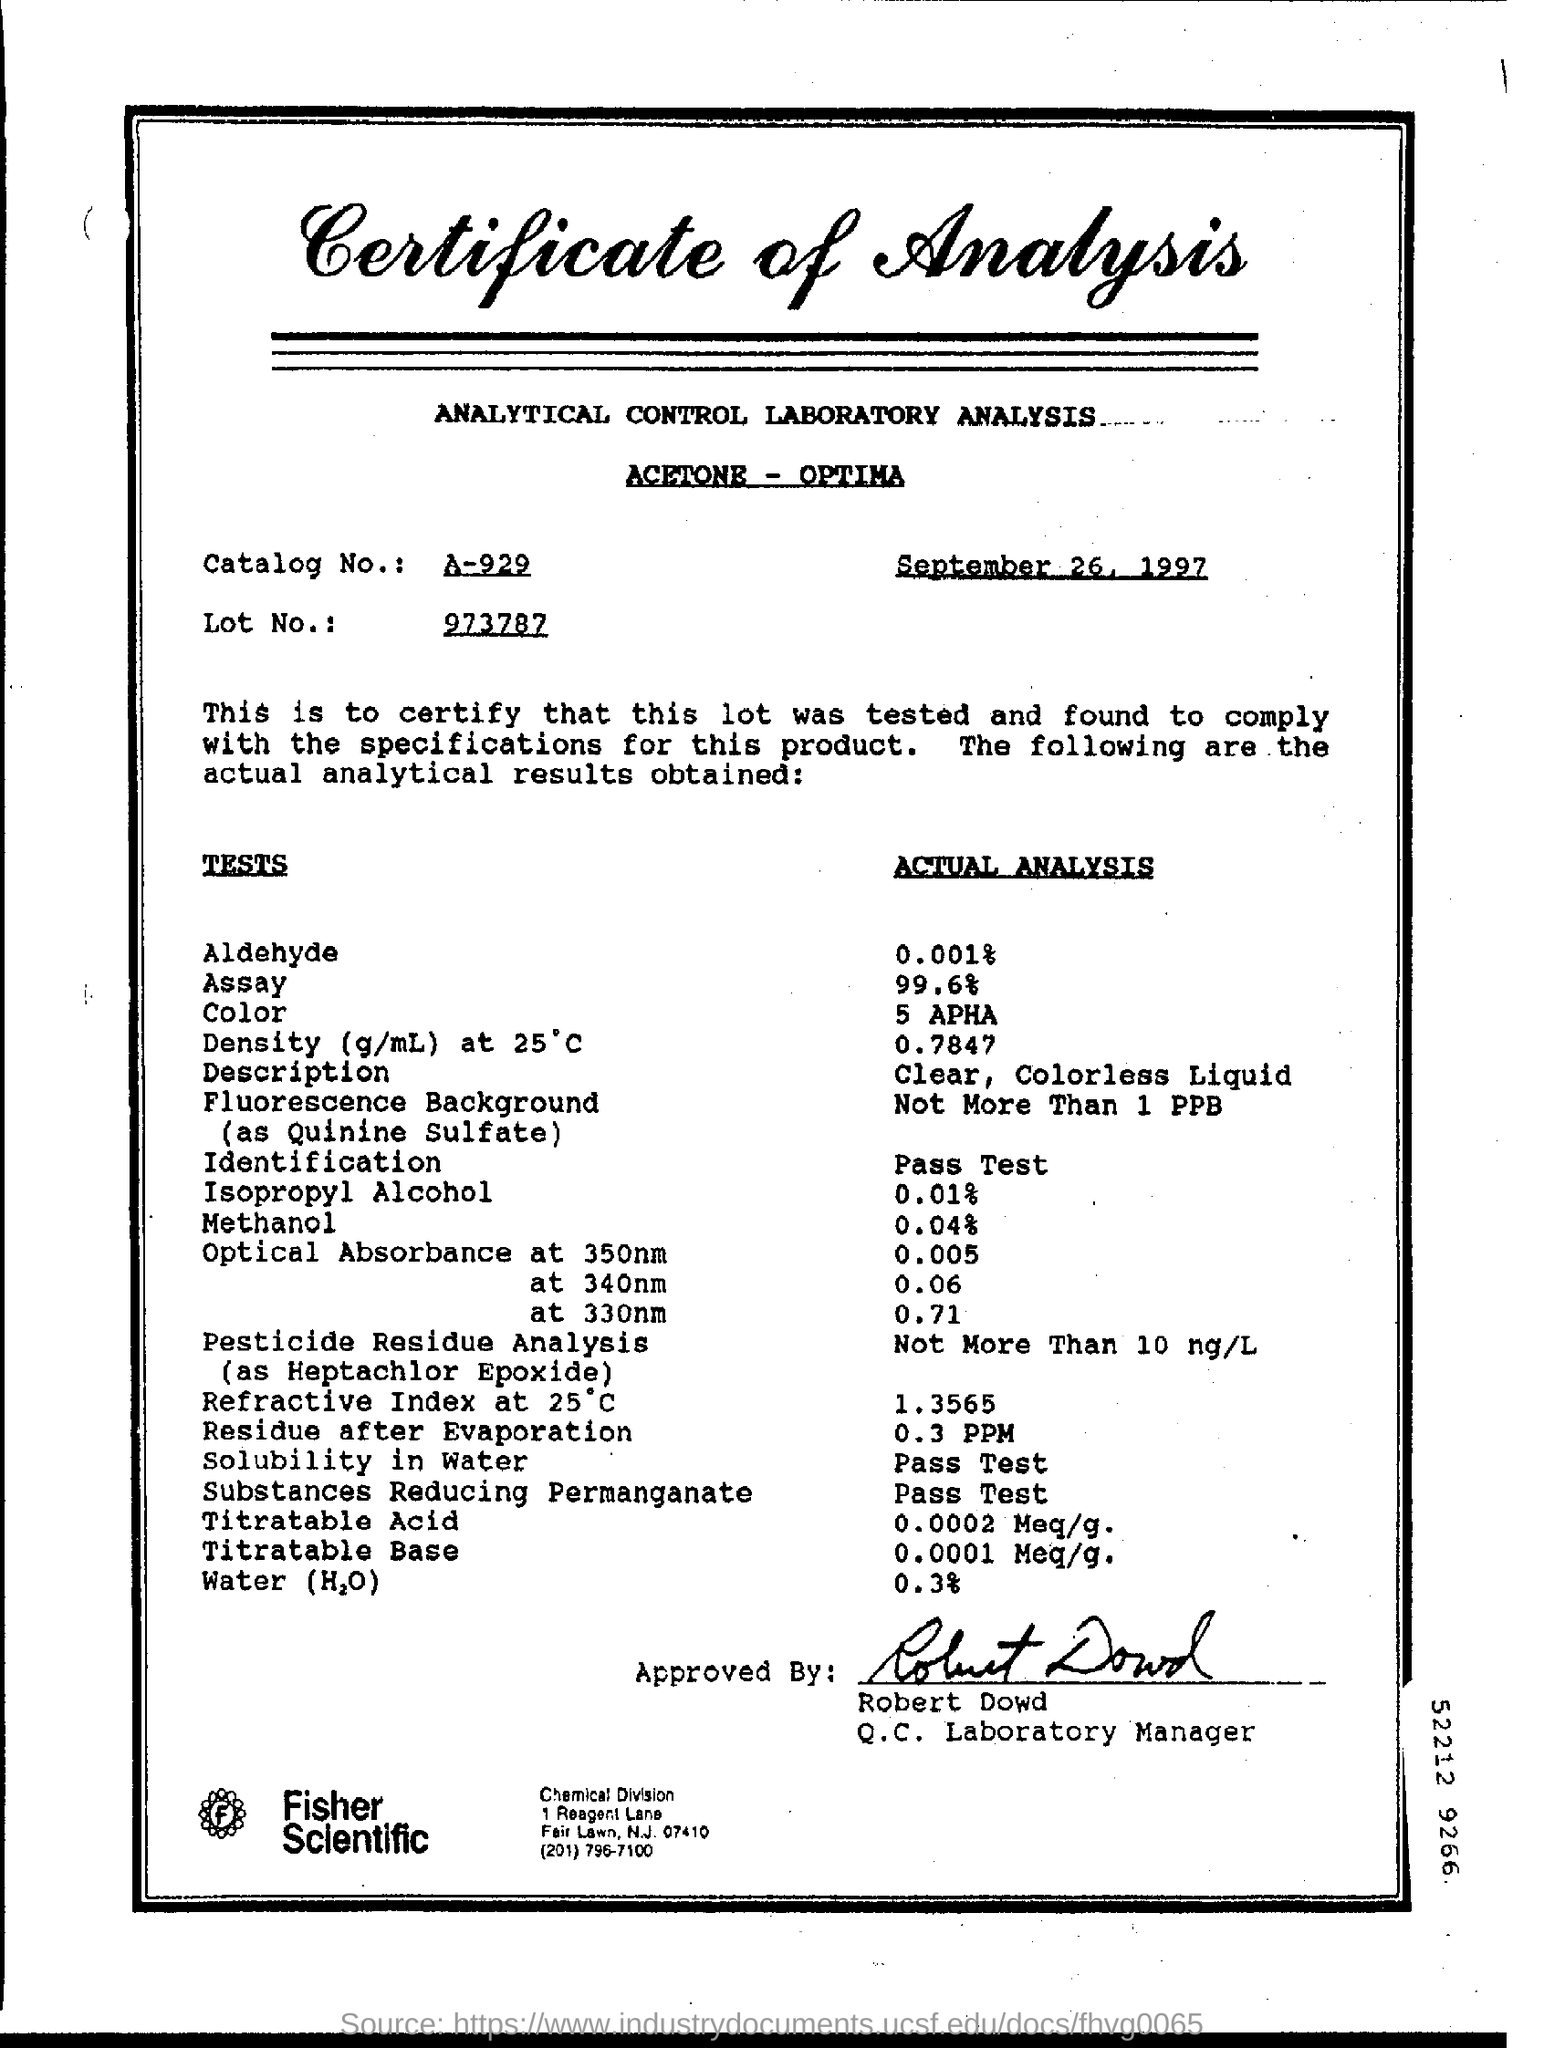Draw attention to some important aspects in this diagram. The date mentioned at the top of the document is September 26, 1997. The letterhead contains a Certificate of Analysis. The Q.C. Laboratory Manager's name is Robert Dowd. The catalog number is A-929. Actual Analysis is a clear, colorless liquid that provides a detailed description of its subject. 